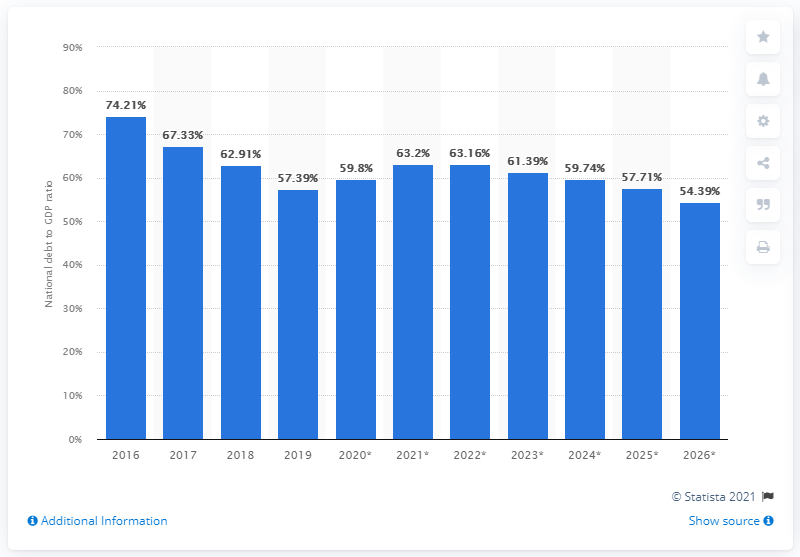Draw attention to some important aspects in this diagram. In 2019, Ireland's national debt accounted for 57.71% of the country's gross domestic product. 